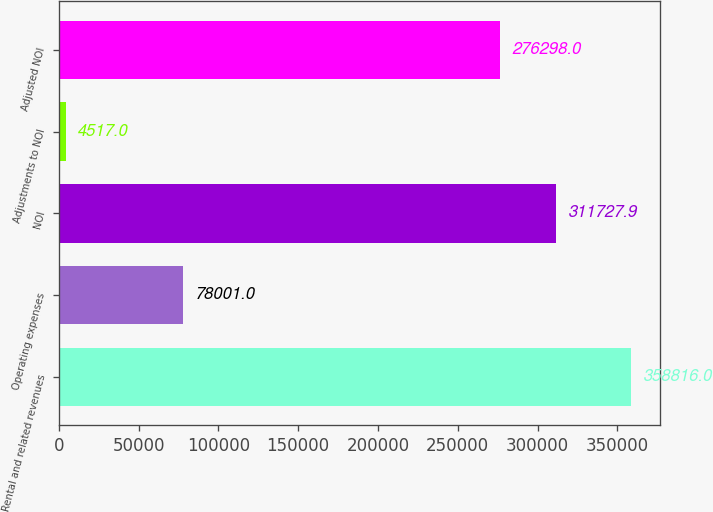Convert chart. <chart><loc_0><loc_0><loc_500><loc_500><bar_chart><fcel>Rental and related revenues<fcel>Operating expenses<fcel>NOI<fcel>Adjustments to NOI<fcel>Adjusted NOI<nl><fcel>358816<fcel>78001<fcel>311728<fcel>4517<fcel>276298<nl></chart> 